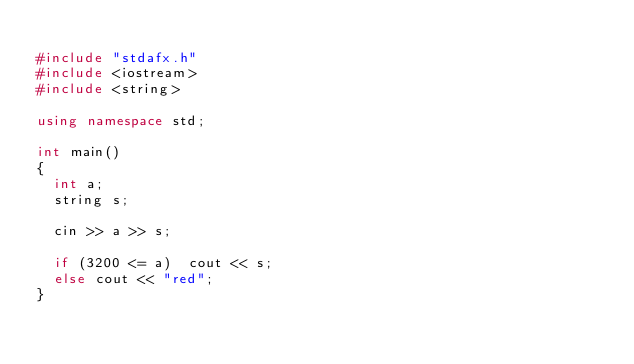Convert code to text. <code><loc_0><loc_0><loc_500><loc_500><_C++_>
#include "stdafx.h"
#include <iostream>
#include <string>

using namespace std;

int main()
{
	int a;
	string s;

	cin >> a >> s;

	if (3200 <= a)	cout << s;
	else cout << "red";
}

</code> 